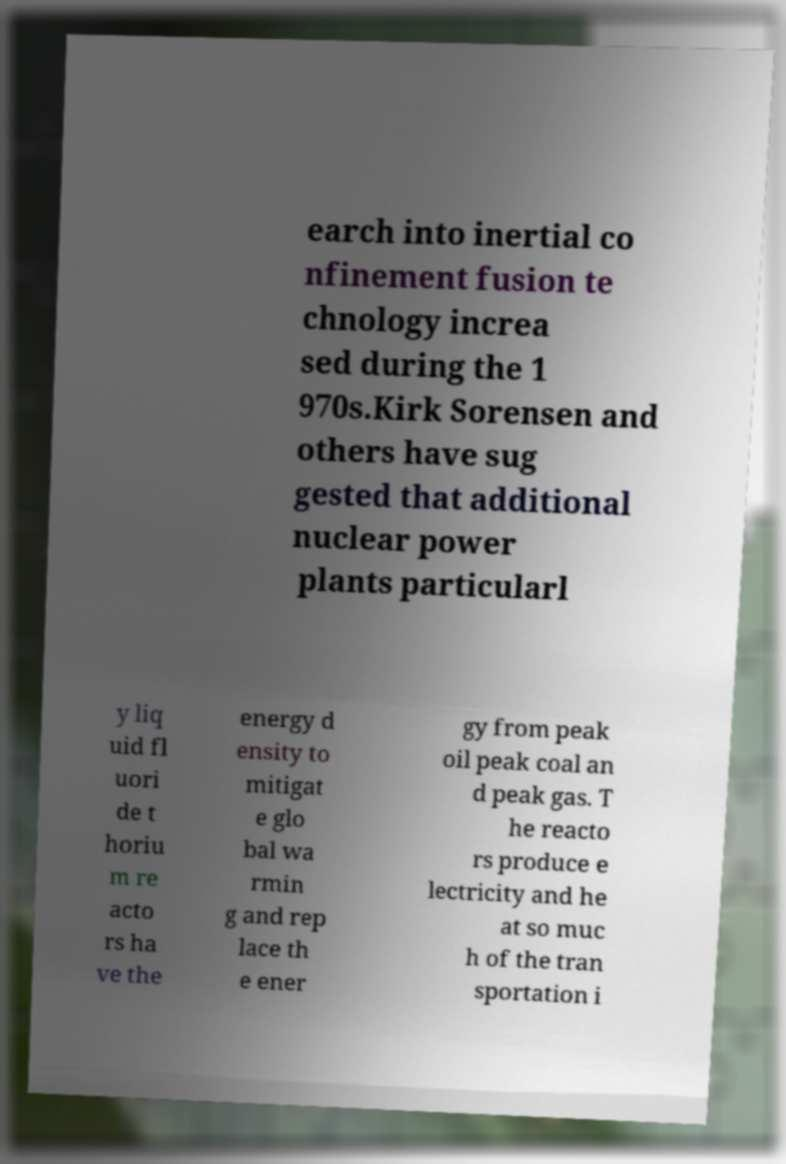For documentation purposes, I need the text within this image transcribed. Could you provide that? earch into inertial co nfinement fusion te chnology increa sed during the 1 970s.Kirk Sorensen and others have sug gested that additional nuclear power plants particularl y liq uid fl uori de t horiu m re acto rs ha ve the energy d ensity to mitigat e glo bal wa rmin g and rep lace th e ener gy from peak oil peak coal an d peak gas. T he reacto rs produce e lectricity and he at so muc h of the tran sportation i 